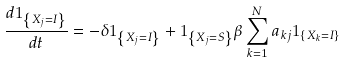Convert formula to latex. <formula><loc_0><loc_0><loc_500><loc_500>\frac { d 1 _ { \left \{ X _ { j } = I \right \} } } { d t } = - \delta 1 _ { \left \{ X _ { j } = I \right \} } + 1 _ { \left \{ X _ { j } = S \right \} } \beta \sum _ { k = 1 } ^ { N } a _ { k j } 1 _ { \left \{ X _ { k } = I \right \} }</formula> 